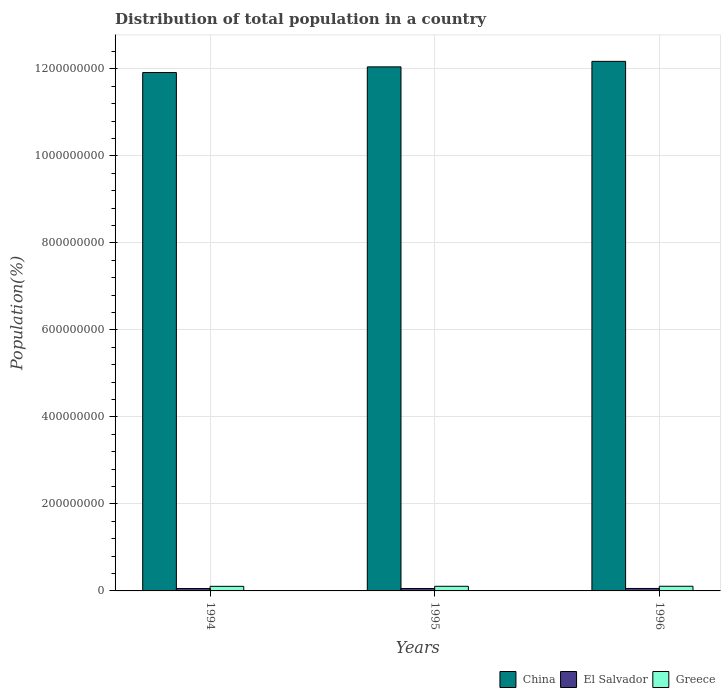Are the number of bars per tick equal to the number of legend labels?
Offer a terse response. Yes. Are the number of bars on each tick of the X-axis equal?
Provide a succinct answer. Yes. What is the label of the 1st group of bars from the left?
Keep it short and to the point. 1994. What is the population of in El Salvador in 1995?
Your answer should be very brief. 5.59e+06. Across all years, what is the maximum population of in El Salvador?
Keep it short and to the point. 5.64e+06. Across all years, what is the minimum population of in El Salvador?
Offer a very short reply. 5.53e+06. In which year was the population of in Greece maximum?
Give a very brief answer. 1996. In which year was the population of in China minimum?
Keep it short and to the point. 1994. What is the total population of in Greece in the graph?
Make the answer very short. 3.19e+07. What is the difference between the population of in China in 1994 and that in 1996?
Keep it short and to the point. -2.57e+07. What is the difference between the population of in Greece in 1996 and the population of in China in 1994?
Offer a very short reply. -1.18e+09. What is the average population of in Greece per year?
Ensure brevity in your answer.  1.06e+07. In the year 1995, what is the difference between the population of in China and population of in Greece?
Your answer should be very brief. 1.19e+09. What is the ratio of the population of in Greece in 1994 to that in 1995?
Provide a succinct answer. 0.99. Is the population of in China in 1995 less than that in 1996?
Your response must be concise. Yes. What is the difference between the highest and the second highest population of in China?
Give a very brief answer. 1.27e+07. What is the difference between the highest and the lowest population of in Greece?
Offer a very short reply. 1.56e+05. In how many years, is the population of in China greater than the average population of in China taken over all years?
Give a very brief answer. 2. What does the 1st bar from the left in 1996 represents?
Offer a terse response. China. How many bars are there?
Keep it short and to the point. 9. Are the values on the major ticks of Y-axis written in scientific E-notation?
Provide a short and direct response. No. Where does the legend appear in the graph?
Make the answer very short. Bottom right. How many legend labels are there?
Your answer should be compact. 3. What is the title of the graph?
Ensure brevity in your answer.  Distribution of total population in a country. Does "World" appear as one of the legend labels in the graph?
Give a very brief answer. No. What is the label or title of the X-axis?
Your answer should be very brief. Years. What is the label or title of the Y-axis?
Keep it short and to the point. Population(%). What is the Population(%) in China in 1994?
Offer a terse response. 1.19e+09. What is the Population(%) of El Salvador in 1994?
Provide a short and direct response. 5.53e+06. What is the Population(%) in Greece in 1994?
Make the answer very short. 1.06e+07. What is the Population(%) in China in 1995?
Provide a short and direct response. 1.20e+09. What is the Population(%) in El Salvador in 1995?
Your response must be concise. 5.59e+06. What is the Population(%) in Greece in 1995?
Provide a short and direct response. 1.06e+07. What is the Population(%) in China in 1996?
Give a very brief answer. 1.22e+09. What is the Population(%) in El Salvador in 1996?
Offer a very short reply. 5.64e+06. What is the Population(%) in Greece in 1996?
Give a very brief answer. 1.07e+07. Across all years, what is the maximum Population(%) in China?
Your answer should be very brief. 1.22e+09. Across all years, what is the maximum Population(%) in El Salvador?
Your answer should be compact. 5.64e+06. Across all years, what is the maximum Population(%) of Greece?
Offer a very short reply. 1.07e+07. Across all years, what is the minimum Population(%) of China?
Offer a terse response. 1.19e+09. Across all years, what is the minimum Population(%) in El Salvador?
Provide a succinct answer. 5.53e+06. Across all years, what is the minimum Population(%) of Greece?
Your answer should be very brief. 1.06e+07. What is the total Population(%) in China in the graph?
Give a very brief answer. 3.61e+09. What is the total Population(%) in El Salvador in the graph?
Offer a very short reply. 1.68e+07. What is the total Population(%) of Greece in the graph?
Your answer should be compact. 3.19e+07. What is the difference between the Population(%) of China in 1994 and that in 1995?
Your answer should be compact. -1.30e+07. What is the difference between the Population(%) in El Salvador in 1994 and that in 1995?
Ensure brevity in your answer.  -6.07e+04. What is the difference between the Population(%) of Greece in 1994 and that in 1995?
Your answer should be compact. -8.14e+04. What is the difference between the Population(%) of China in 1994 and that in 1996?
Offer a terse response. -2.57e+07. What is the difference between the Population(%) of El Salvador in 1994 and that in 1996?
Your response must be concise. -1.15e+05. What is the difference between the Population(%) of Greece in 1994 and that in 1996?
Your answer should be very brief. -1.56e+05. What is the difference between the Population(%) of China in 1995 and that in 1996?
Keep it short and to the point. -1.27e+07. What is the difference between the Population(%) of El Salvador in 1995 and that in 1996?
Provide a short and direct response. -5.46e+04. What is the difference between the Population(%) in Greece in 1995 and that in 1996?
Provide a succinct answer. -7.48e+04. What is the difference between the Population(%) of China in 1994 and the Population(%) of El Salvador in 1995?
Your answer should be compact. 1.19e+09. What is the difference between the Population(%) of China in 1994 and the Population(%) of Greece in 1995?
Keep it short and to the point. 1.18e+09. What is the difference between the Population(%) of El Salvador in 1994 and the Population(%) of Greece in 1995?
Provide a succinct answer. -5.11e+06. What is the difference between the Population(%) in China in 1994 and the Population(%) in El Salvador in 1996?
Keep it short and to the point. 1.19e+09. What is the difference between the Population(%) of China in 1994 and the Population(%) of Greece in 1996?
Provide a short and direct response. 1.18e+09. What is the difference between the Population(%) in El Salvador in 1994 and the Population(%) in Greece in 1996?
Offer a very short reply. -5.18e+06. What is the difference between the Population(%) in China in 1995 and the Population(%) in El Salvador in 1996?
Offer a very short reply. 1.20e+09. What is the difference between the Population(%) of China in 1995 and the Population(%) of Greece in 1996?
Provide a short and direct response. 1.19e+09. What is the difference between the Population(%) in El Salvador in 1995 and the Population(%) in Greece in 1996?
Your answer should be compact. -5.12e+06. What is the average Population(%) in China per year?
Give a very brief answer. 1.20e+09. What is the average Population(%) in El Salvador per year?
Provide a succinct answer. 5.59e+06. What is the average Population(%) of Greece per year?
Your answer should be compact. 1.06e+07. In the year 1994, what is the difference between the Population(%) of China and Population(%) of El Salvador?
Give a very brief answer. 1.19e+09. In the year 1994, what is the difference between the Population(%) of China and Population(%) of Greece?
Provide a succinct answer. 1.18e+09. In the year 1994, what is the difference between the Population(%) of El Salvador and Population(%) of Greece?
Your response must be concise. -5.03e+06. In the year 1995, what is the difference between the Population(%) of China and Population(%) of El Salvador?
Offer a very short reply. 1.20e+09. In the year 1995, what is the difference between the Population(%) of China and Population(%) of Greece?
Give a very brief answer. 1.19e+09. In the year 1995, what is the difference between the Population(%) in El Salvador and Population(%) in Greece?
Keep it short and to the point. -5.05e+06. In the year 1996, what is the difference between the Population(%) in China and Population(%) in El Salvador?
Offer a terse response. 1.21e+09. In the year 1996, what is the difference between the Population(%) of China and Population(%) of Greece?
Your answer should be very brief. 1.21e+09. In the year 1996, what is the difference between the Population(%) of El Salvador and Population(%) of Greece?
Ensure brevity in your answer.  -5.07e+06. What is the ratio of the Population(%) in China in 1994 to that in 1995?
Give a very brief answer. 0.99. What is the ratio of the Population(%) of El Salvador in 1994 to that in 1995?
Provide a short and direct response. 0.99. What is the ratio of the Population(%) of Greece in 1994 to that in 1995?
Your response must be concise. 0.99. What is the ratio of the Population(%) of China in 1994 to that in 1996?
Provide a succinct answer. 0.98. What is the ratio of the Population(%) in El Salvador in 1994 to that in 1996?
Make the answer very short. 0.98. What is the ratio of the Population(%) of Greece in 1994 to that in 1996?
Give a very brief answer. 0.99. What is the ratio of the Population(%) of El Salvador in 1995 to that in 1996?
Ensure brevity in your answer.  0.99. What is the ratio of the Population(%) in Greece in 1995 to that in 1996?
Make the answer very short. 0.99. What is the difference between the highest and the second highest Population(%) in China?
Keep it short and to the point. 1.27e+07. What is the difference between the highest and the second highest Population(%) in El Salvador?
Your answer should be compact. 5.46e+04. What is the difference between the highest and the second highest Population(%) in Greece?
Your answer should be compact. 7.48e+04. What is the difference between the highest and the lowest Population(%) in China?
Offer a very short reply. 2.57e+07. What is the difference between the highest and the lowest Population(%) of El Salvador?
Your answer should be very brief. 1.15e+05. What is the difference between the highest and the lowest Population(%) of Greece?
Ensure brevity in your answer.  1.56e+05. 